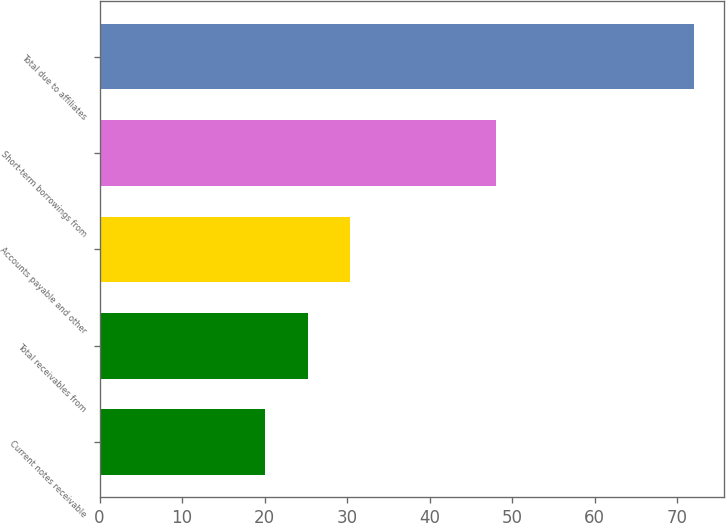<chart> <loc_0><loc_0><loc_500><loc_500><bar_chart><fcel>Current notes receivable<fcel>Total receivables from<fcel>Accounts payable and other<fcel>Short-term borrowings from<fcel>Total due to affiliates<nl><fcel>20<fcel>25.2<fcel>30.4<fcel>48<fcel>72<nl></chart> 